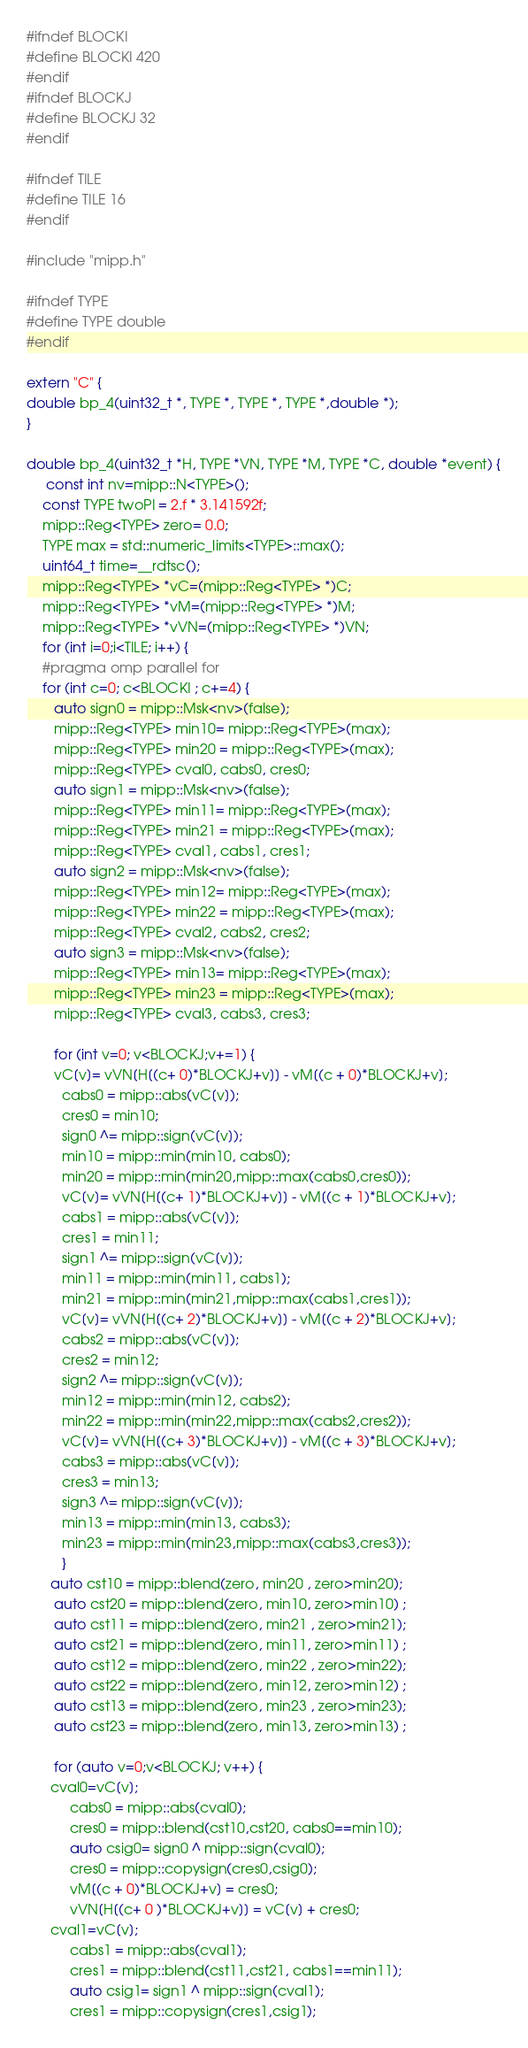<code> <loc_0><loc_0><loc_500><loc_500><_C++_>#ifndef BLOCKI
#define BLOCKI 420
#endif
#ifndef BLOCKJ
#define BLOCKJ 32
#endif

#ifndef TILE
#define TILE 16
#endif

#include "mipp.h"

#ifndef TYPE
#define TYPE double
#endif

extern "C" {
double bp_4(uint32_t *, TYPE *, TYPE *, TYPE *,double *);
}

double bp_4(uint32_t *H, TYPE *VN, TYPE *M, TYPE *C, double *event) {
     const int nv=mipp::N<TYPE>();                     
    const TYPE twoPI = 2.f * 3.141592f;
    mipp::Reg<TYPE> zero= 0.0;
    TYPE max = std::numeric_limits<TYPE>::max();
    uint64_t time=__rdtsc();
    mipp::Reg<TYPE> *vC=(mipp::Reg<TYPE> *)C;
    mipp::Reg<TYPE> *vM=(mipp::Reg<TYPE> *)M;
    mipp::Reg<TYPE> *vVN=(mipp::Reg<TYPE> *)VN;
    for (int i=0;i<TILE; i++) {
    #pragma omp parallel for
    for (int c=0; c<BLOCKI ; c+=4) {
       auto sign0 = mipp::Msk<nv>(false);
       mipp::Reg<TYPE> min10= mipp::Reg<TYPE>(max);
       mipp::Reg<TYPE> min20 = mipp::Reg<TYPE>(max);
       mipp::Reg<TYPE> cval0, cabs0, cres0;
       auto sign1 = mipp::Msk<nv>(false);
       mipp::Reg<TYPE> min11= mipp::Reg<TYPE>(max);
       mipp::Reg<TYPE> min21 = mipp::Reg<TYPE>(max);
       mipp::Reg<TYPE> cval1, cabs1, cres1;
       auto sign2 = mipp::Msk<nv>(false);
       mipp::Reg<TYPE> min12= mipp::Reg<TYPE>(max);
       mipp::Reg<TYPE> min22 = mipp::Reg<TYPE>(max);
       mipp::Reg<TYPE> cval2, cabs2, cres2;
       auto sign3 = mipp::Msk<nv>(false);
       mipp::Reg<TYPE> min13= mipp::Reg<TYPE>(max);
       mipp::Reg<TYPE> min23 = mipp::Reg<TYPE>(max);
       mipp::Reg<TYPE> cval3, cabs3, cres3;
       
       for (int v=0; v<BLOCKJ;v+=1) {
       vC[v]= vVN[H[(c+ 0)*BLOCKJ+v]] - vM[(c + 0)*BLOCKJ+v];
         cabs0 = mipp::abs(vC[v]);
         cres0 = min10;
         sign0 ^= mipp::sign(vC[v]);
         min10 = mipp::min(min10, cabs0);
         min20 = mipp::min(min20,mipp::max(cabs0,cres0));
         vC[v]= vVN[H[(c+ 1)*BLOCKJ+v]] - vM[(c + 1)*BLOCKJ+v];
         cabs1 = mipp::abs(vC[v]);
         cres1 = min11;
         sign1 ^= mipp::sign(vC[v]);
         min11 = mipp::min(min11, cabs1);
         min21 = mipp::min(min21,mipp::max(cabs1,cres1));
         vC[v]= vVN[H[(c+ 2)*BLOCKJ+v]] - vM[(c + 2)*BLOCKJ+v];
         cabs2 = mipp::abs(vC[v]);
         cres2 = min12;
         sign2 ^= mipp::sign(vC[v]);
         min12 = mipp::min(min12, cabs2);
         min22 = mipp::min(min22,mipp::max(cabs2,cres2));
         vC[v]= vVN[H[(c+ 3)*BLOCKJ+v]] - vM[(c + 3)*BLOCKJ+v];
         cabs3 = mipp::abs(vC[v]);
         cres3 = min13;
         sign3 ^= mipp::sign(vC[v]);
         min13 = mipp::min(min13, cabs3);
         min23 = mipp::min(min23,mipp::max(cabs3,cres3));
         }
      auto cst10 = mipp::blend(zero, min20 , zero>min20);
       auto cst20 = mipp::blend(zero, min10, zero>min10) ;
       auto cst11 = mipp::blend(zero, min21 , zero>min21);
       auto cst21 = mipp::blend(zero, min11, zero>min11) ;
       auto cst12 = mipp::blend(zero, min22 , zero>min22);
       auto cst22 = mipp::blend(zero, min12, zero>min12) ;
       auto cst13 = mipp::blend(zero, min23 , zero>min23);
       auto cst23 = mipp::blend(zero, min13, zero>min13) ;
       
       for (auto v=0;v<BLOCKJ; v++) {
      cval0=vC[v];
           cabs0 = mipp::abs(cval0);
           cres0 = mipp::blend(cst10,cst20, cabs0==min10);
           auto csig0= sign0 ^ mipp::sign(cval0);
           cres0 = mipp::copysign(cres0,csig0);
           vM[(c + 0)*BLOCKJ+v] = cres0;
           vVN[H[(c+ 0 )*BLOCKJ+v]] = vC[v] + cres0;
      cval1=vC[v];
           cabs1 = mipp::abs(cval1);
           cres1 = mipp::blend(cst11,cst21, cabs1==min11);
           auto csig1= sign1 ^ mipp::sign(cval1);
           cres1 = mipp::copysign(cres1,csig1);</code> 